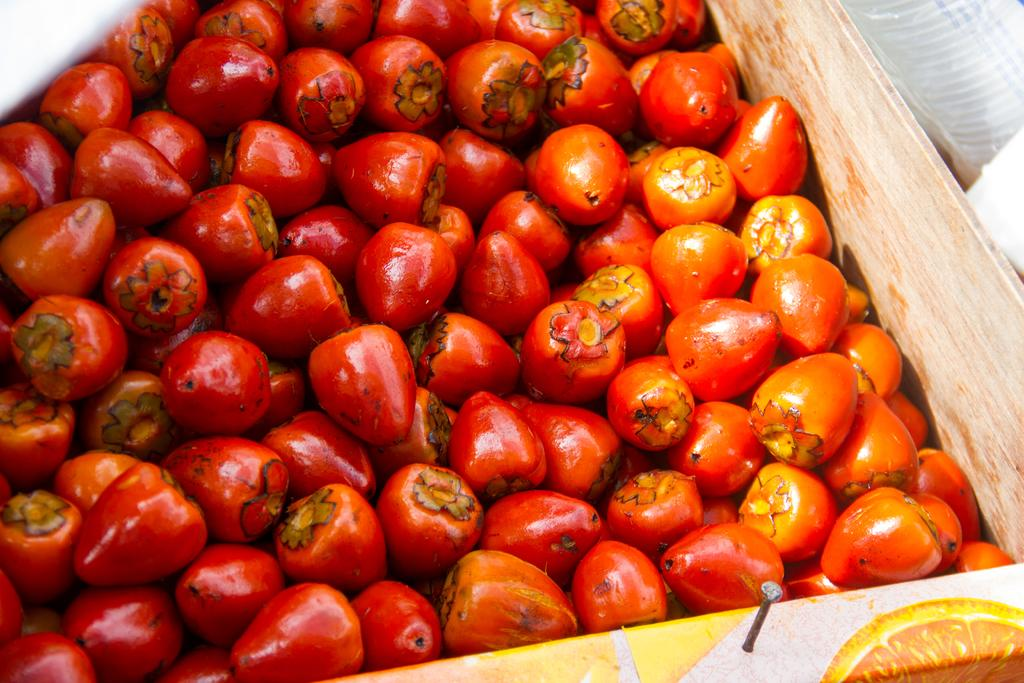What type of plants are in the image? There are peach palms in the image. Where are the peach palms located? The peach palms are in a container. What time does the clock show in the image? There is no clock present in the image. What is the condition of the person's throat in the image? There is no person or reference to a throat in the image. 